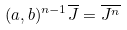<formula> <loc_0><loc_0><loc_500><loc_500>( a , b ) ^ { n - 1 } \overline { J } = \overline { J ^ { n } }</formula> 